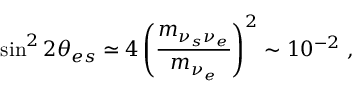Convert formula to latex. <formula><loc_0><loc_0><loc_500><loc_500>\sin ^ { 2 } 2 \theta _ { e s } \simeq 4 \left ( \frac { m _ { \nu _ { s } \nu _ { e } } } { m _ { \nu _ { e } } } \right ) ^ { 2 } \sim 1 0 ^ { - 2 } ,</formula> 